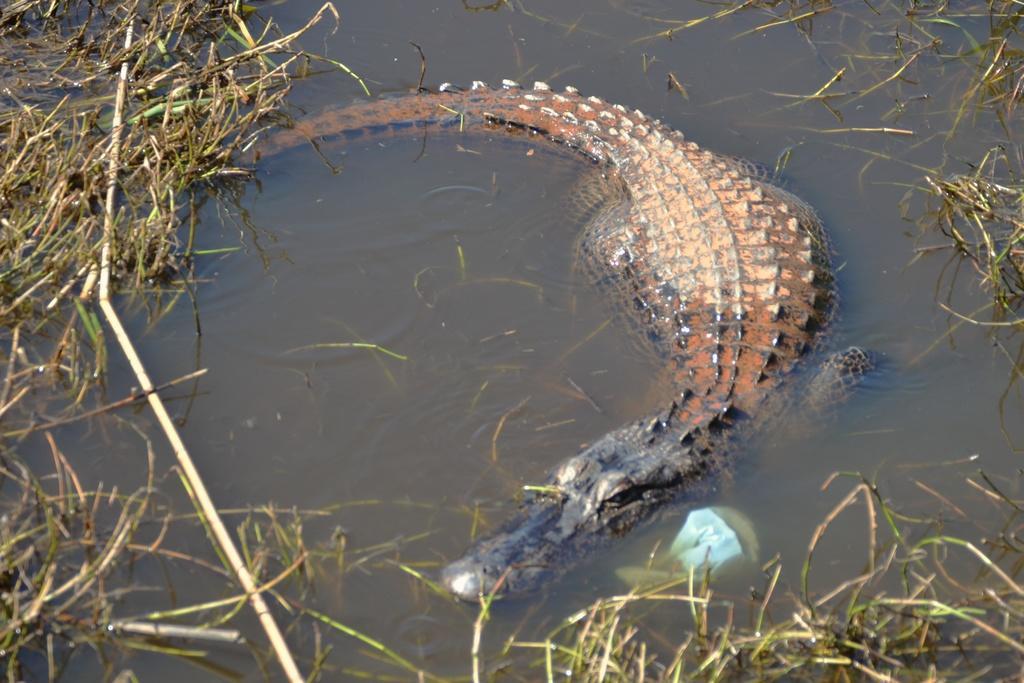Can you describe this image briefly? In this image, I can see a crocodile and plants in the water. 